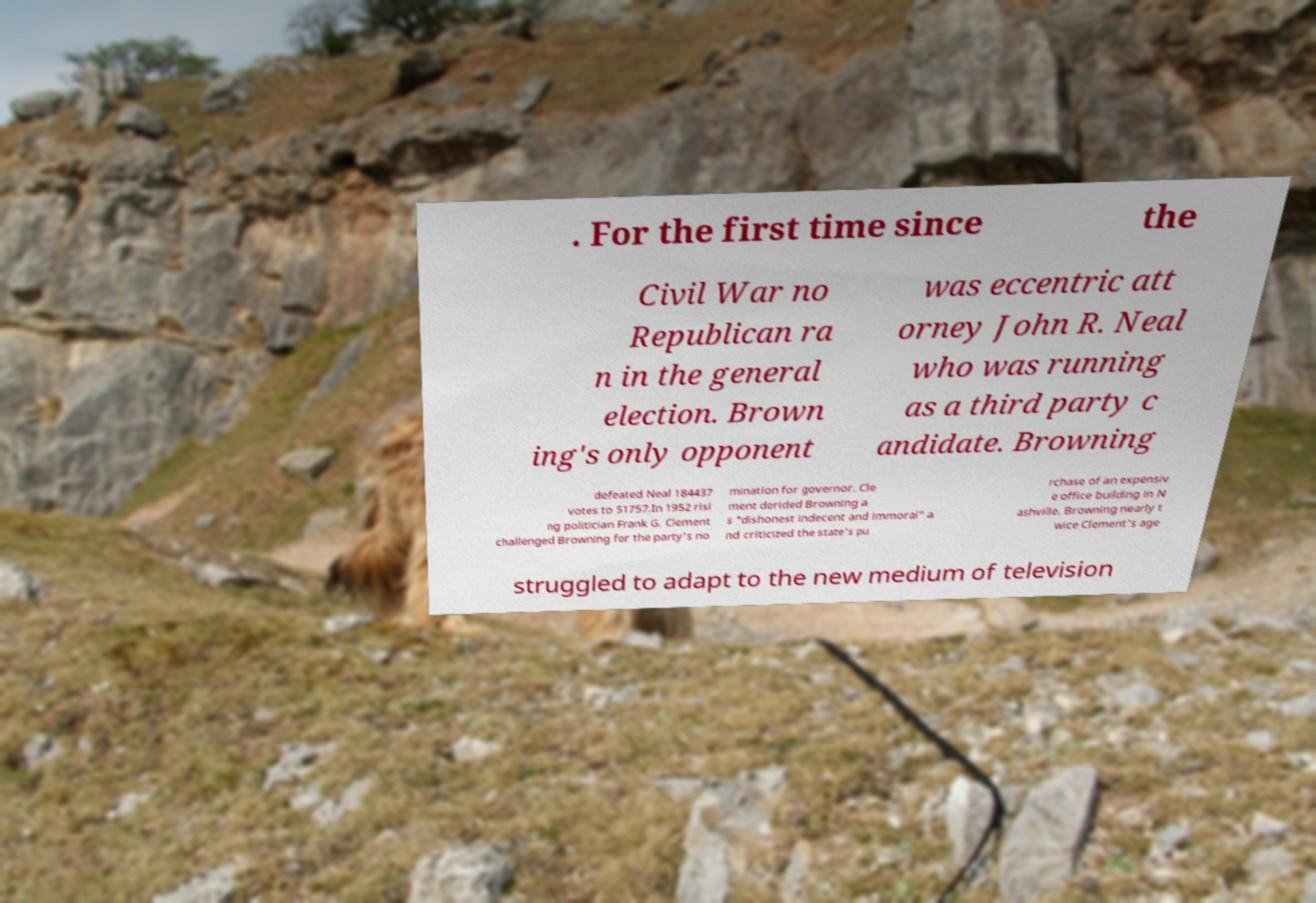There's text embedded in this image that I need extracted. Can you transcribe it verbatim? . For the first time since the Civil War no Republican ra n in the general election. Brown ing's only opponent was eccentric att orney John R. Neal who was running as a third party c andidate. Browning defeated Neal 184437 votes to 51757.In 1952 risi ng politician Frank G. Clement challenged Browning for the party's no mination for governor. Cle ment derided Browning a s "dishonest indecent and immoral" a nd criticized the state's pu rchase of an expensiv e office building in N ashville. Browning nearly t wice Clement's age struggled to adapt to the new medium of television 